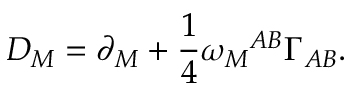Convert formula to latex. <formula><loc_0><loc_0><loc_500><loc_500>D _ { M } = \partial _ { M } + \frac { 1 } { 4 } \omega _ { M ^ { A B } \Gamma _ { A B } .</formula> 